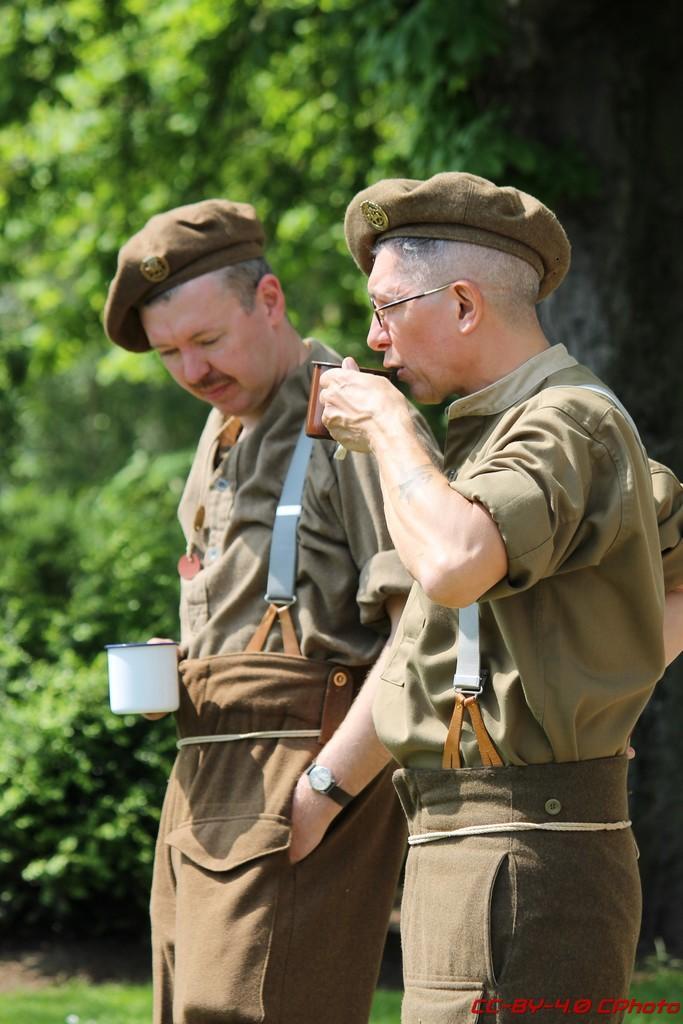Could you give a brief overview of what you see in this image? In the image in the front there are persons standing and holding cups in their hands. In the background there are trees. In the front there is a man standing and drinking. 